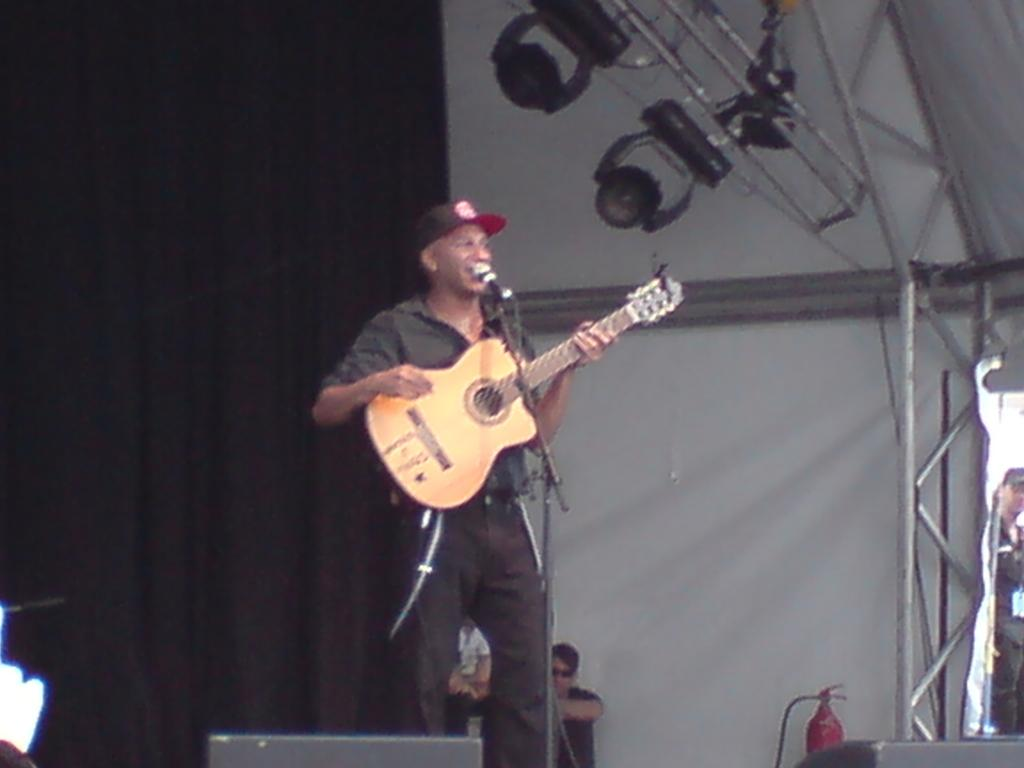How many people are in the image? There are three members in the image. What is the man in front holding? The man in front is holding a guitar. What equipment is present for amplifying sound in the image? There is a microphone and a microphone stand in the image. What can be seen in the background of the image? There is a curtain in the background of the image. What color is the orange in the image? There is no orange present in the image. How is the man measuring the distance between the microphone and the microphone stand in the image? The man is not measuring the distance between the microphone and the microphone stand in the image; he is simply holding a guitar. 